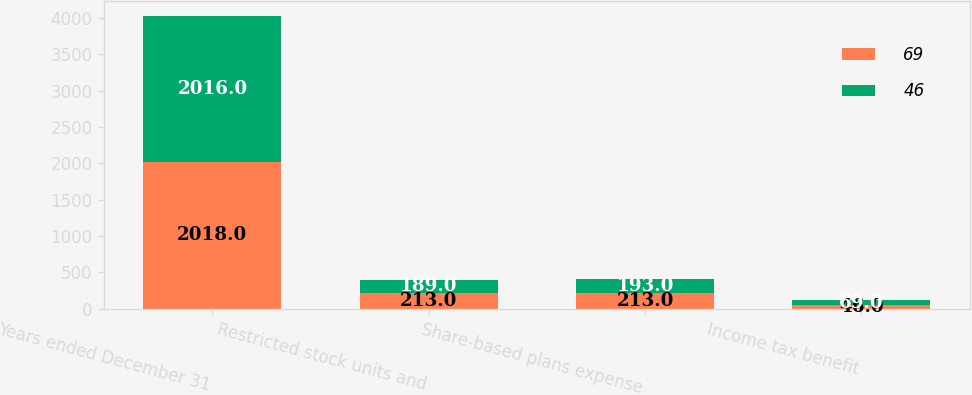<chart> <loc_0><loc_0><loc_500><loc_500><stacked_bar_chart><ecel><fcel>Years ended December 31<fcel>Restricted stock units and<fcel>Share-based plans expense<fcel>Income tax benefit<nl><fcel>69<fcel>2018<fcel>213<fcel>213<fcel>46<nl><fcel>46<fcel>2016<fcel>189<fcel>193<fcel>69<nl></chart> 